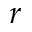<formula> <loc_0><loc_0><loc_500><loc_500>r</formula> 